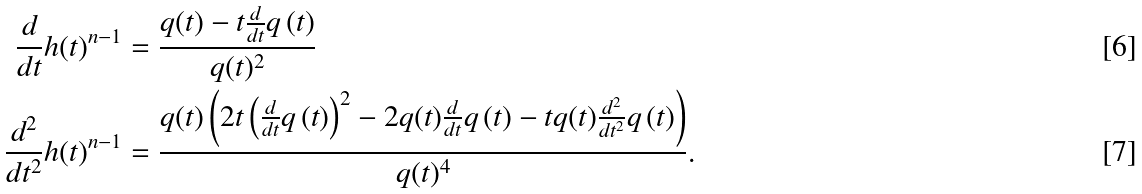<formula> <loc_0><loc_0><loc_500><loc_500>\frac { d } { d t } h ( t ) ^ { n - 1 } & = \frac { q ( t ) - t \frac { d } { d t } q \left ( t \right ) } { q ( t ) ^ { 2 } } \\ \frac { d ^ { 2 } } { d t ^ { 2 } } h ( t ) ^ { n - 1 } & = \frac { q ( t ) \left ( 2 t \left ( \frac { d } { d t } q \left ( t \right ) \right ) ^ { 2 } - 2 q ( t ) \frac { d } { d t } q \left ( t \right ) - t q ( t ) \frac { d ^ { 2 } } { d t ^ { 2 } } q \left ( t \right ) \right ) } { q ( t ) ^ { 4 } } .</formula> 